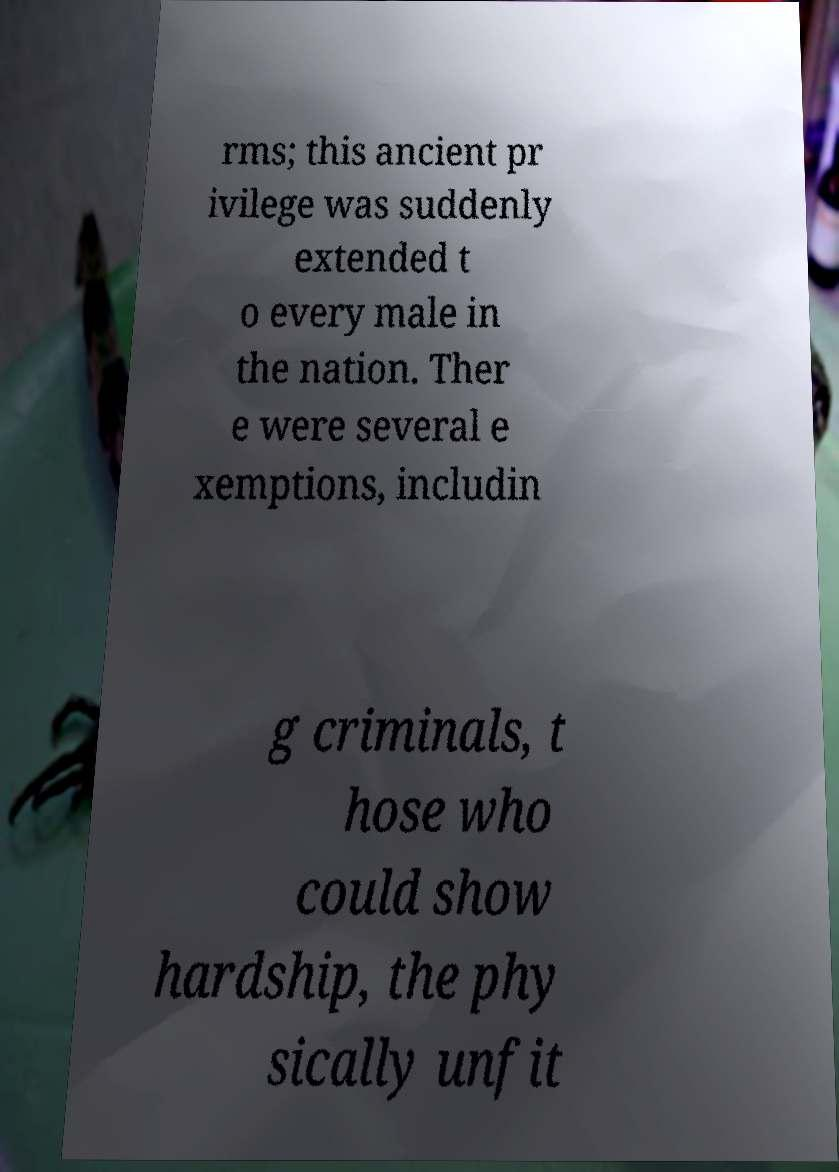Could you extract and type out the text from this image? rms; this ancient pr ivilege was suddenly extended t o every male in the nation. Ther e were several e xemptions, includin g criminals, t hose who could show hardship, the phy sically unfit 